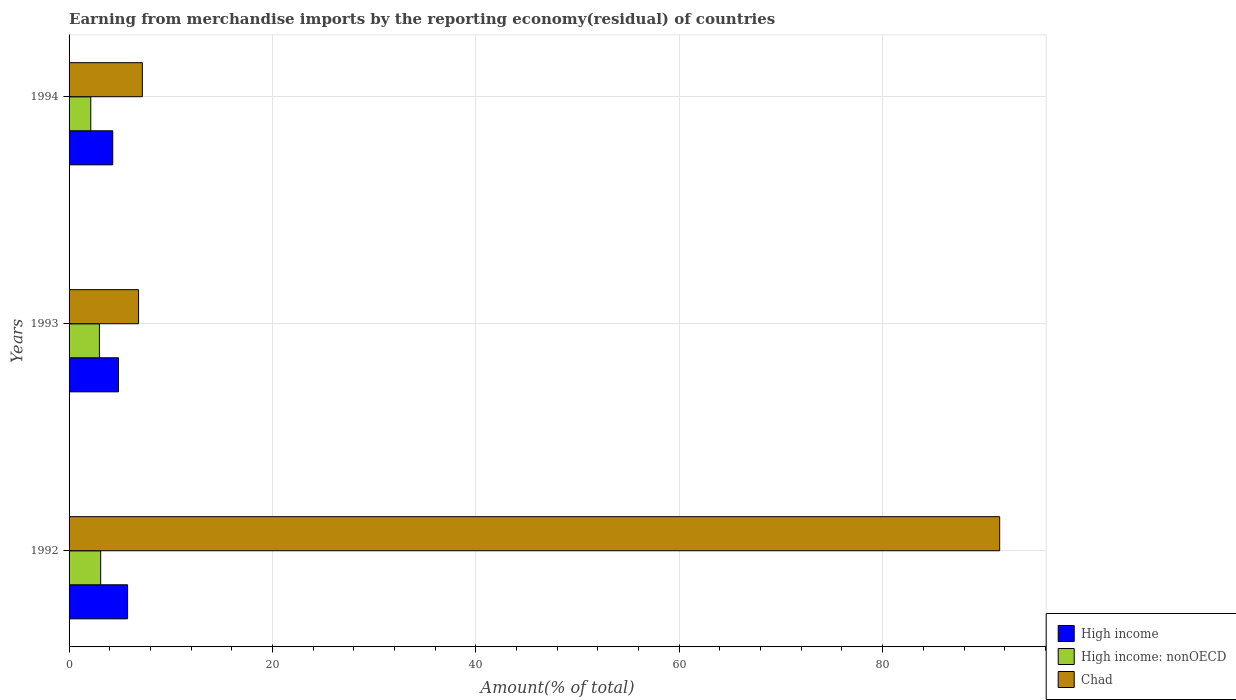How many different coloured bars are there?
Keep it short and to the point. 3. Are the number of bars per tick equal to the number of legend labels?
Make the answer very short. Yes. How many bars are there on the 3rd tick from the top?
Your response must be concise. 3. What is the label of the 1st group of bars from the top?
Offer a very short reply. 1994. What is the percentage of amount earned from merchandise imports in High income: nonOECD in 1994?
Provide a succinct answer. 2.13. Across all years, what is the maximum percentage of amount earned from merchandise imports in High income?
Provide a succinct answer. 5.75. Across all years, what is the minimum percentage of amount earned from merchandise imports in Chad?
Your answer should be compact. 6.83. In which year was the percentage of amount earned from merchandise imports in Chad maximum?
Give a very brief answer. 1992. What is the total percentage of amount earned from merchandise imports in High income: nonOECD in the graph?
Give a very brief answer. 8.23. What is the difference between the percentage of amount earned from merchandise imports in High income in 1992 and that in 1993?
Offer a terse response. 0.89. What is the difference between the percentage of amount earned from merchandise imports in High income: nonOECD in 1992 and the percentage of amount earned from merchandise imports in High income in 1994?
Provide a succinct answer. -1.19. What is the average percentage of amount earned from merchandise imports in Chad per year?
Make the answer very short. 35.18. In the year 1993, what is the difference between the percentage of amount earned from merchandise imports in High income and percentage of amount earned from merchandise imports in Chad?
Ensure brevity in your answer.  -1.97. What is the ratio of the percentage of amount earned from merchandise imports in High income: nonOECD in 1992 to that in 1993?
Ensure brevity in your answer.  1.04. Is the percentage of amount earned from merchandise imports in High income: nonOECD in 1992 less than that in 1993?
Ensure brevity in your answer.  No. Is the difference between the percentage of amount earned from merchandise imports in High income in 1992 and 1993 greater than the difference between the percentage of amount earned from merchandise imports in Chad in 1992 and 1993?
Make the answer very short. No. What is the difference between the highest and the second highest percentage of amount earned from merchandise imports in Chad?
Keep it short and to the point. 84.3. What is the difference between the highest and the lowest percentage of amount earned from merchandise imports in High income: nonOECD?
Your response must be concise. 0.97. In how many years, is the percentage of amount earned from merchandise imports in High income greater than the average percentage of amount earned from merchandise imports in High income taken over all years?
Provide a short and direct response. 1. What does the 2nd bar from the top in 1992 represents?
Keep it short and to the point. High income: nonOECD. Are all the bars in the graph horizontal?
Ensure brevity in your answer.  Yes. How many years are there in the graph?
Provide a succinct answer. 3. Does the graph contain any zero values?
Provide a succinct answer. No. How are the legend labels stacked?
Keep it short and to the point. Vertical. What is the title of the graph?
Offer a terse response. Earning from merchandise imports by the reporting economy(residual) of countries. Does "Uganda" appear as one of the legend labels in the graph?
Offer a very short reply. No. What is the label or title of the X-axis?
Your response must be concise. Amount(% of total). What is the label or title of the Y-axis?
Keep it short and to the point. Years. What is the Amount(% of total) in High income in 1992?
Your answer should be very brief. 5.75. What is the Amount(% of total) of High income: nonOECD in 1992?
Your response must be concise. 3.11. What is the Amount(% of total) of Chad in 1992?
Provide a short and direct response. 91.5. What is the Amount(% of total) of High income in 1993?
Give a very brief answer. 4.86. What is the Amount(% of total) in High income: nonOECD in 1993?
Keep it short and to the point. 2.98. What is the Amount(% of total) in Chad in 1993?
Offer a very short reply. 6.83. What is the Amount(% of total) of High income in 1994?
Your response must be concise. 4.3. What is the Amount(% of total) in High income: nonOECD in 1994?
Your answer should be very brief. 2.13. What is the Amount(% of total) in Chad in 1994?
Make the answer very short. 7.21. Across all years, what is the maximum Amount(% of total) of High income?
Provide a short and direct response. 5.75. Across all years, what is the maximum Amount(% of total) in High income: nonOECD?
Ensure brevity in your answer.  3.11. Across all years, what is the maximum Amount(% of total) of Chad?
Ensure brevity in your answer.  91.5. Across all years, what is the minimum Amount(% of total) of High income?
Your response must be concise. 4.3. Across all years, what is the minimum Amount(% of total) of High income: nonOECD?
Provide a short and direct response. 2.13. Across all years, what is the minimum Amount(% of total) in Chad?
Your answer should be very brief. 6.83. What is the total Amount(% of total) of High income in the graph?
Give a very brief answer. 14.91. What is the total Amount(% of total) of High income: nonOECD in the graph?
Ensure brevity in your answer.  8.23. What is the total Amount(% of total) in Chad in the graph?
Give a very brief answer. 105.54. What is the difference between the Amount(% of total) of High income in 1992 and that in 1993?
Your response must be concise. 0.89. What is the difference between the Amount(% of total) in High income: nonOECD in 1992 and that in 1993?
Offer a very short reply. 0.13. What is the difference between the Amount(% of total) in Chad in 1992 and that in 1993?
Your answer should be very brief. 84.67. What is the difference between the Amount(% of total) in High income in 1992 and that in 1994?
Offer a very short reply. 1.46. What is the difference between the Amount(% of total) in High income: nonOECD in 1992 and that in 1994?
Give a very brief answer. 0.97. What is the difference between the Amount(% of total) of Chad in 1992 and that in 1994?
Make the answer very short. 84.3. What is the difference between the Amount(% of total) of High income in 1993 and that in 1994?
Your answer should be compact. 0.56. What is the difference between the Amount(% of total) in High income: nonOECD in 1993 and that in 1994?
Your answer should be compact. 0.85. What is the difference between the Amount(% of total) of Chad in 1993 and that in 1994?
Your answer should be compact. -0.37. What is the difference between the Amount(% of total) of High income in 1992 and the Amount(% of total) of High income: nonOECD in 1993?
Your answer should be compact. 2.77. What is the difference between the Amount(% of total) in High income in 1992 and the Amount(% of total) in Chad in 1993?
Make the answer very short. -1.08. What is the difference between the Amount(% of total) of High income: nonOECD in 1992 and the Amount(% of total) of Chad in 1993?
Provide a short and direct response. -3.72. What is the difference between the Amount(% of total) in High income in 1992 and the Amount(% of total) in High income: nonOECD in 1994?
Make the answer very short. 3.62. What is the difference between the Amount(% of total) of High income in 1992 and the Amount(% of total) of Chad in 1994?
Provide a succinct answer. -1.45. What is the difference between the Amount(% of total) in High income: nonOECD in 1992 and the Amount(% of total) in Chad in 1994?
Keep it short and to the point. -4.1. What is the difference between the Amount(% of total) in High income in 1993 and the Amount(% of total) in High income: nonOECD in 1994?
Your response must be concise. 2.72. What is the difference between the Amount(% of total) in High income in 1993 and the Amount(% of total) in Chad in 1994?
Offer a terse response. -2.35. What is the difference between the Amount(% of total) of High income: nonOECD in 1993 and the Amount(% of total) of Chad in 1994?
Provide a succinct answer. -4.22. What is the average Amount(% of total) in High income per year?
Your answer should be compact. 4.97. What is the average Amount(% of total) in High income: nonOECD per year?
Offer a terse response. 2.74. What is the average Amount(% of total) of Chad per year?
Provide a short and direct response. 35.18. In the year 1992, what is the difference between the Amount(% of total) of High income and Amount(% of total) of High income: nonOECD?
Provide a short and direct response. 2.64. In the year 1992, what is the difference between the Amount(% of total) of High income and Amount(% of total) of Chad?
Provide a succinct answer. -85.75. In the year 1992, what is the difference between the Amount(% of total) in High income: nonOECD and Amount(% of total) in Chad?
Ensure brevity in your answer.  -88.39. In the year 1993, what is the difference between the Amount(% of total) in High income and Amount(% of total) in High income: nonOECD?
Offer a terse response. 1.88. In the year 1993, what is the difference between the Amount(% of total) of High income and Amount(% of total) of Chad?
Offer a very short reply. -1.97. In the year 1993, what is the difference between the Amount(% of total) in High income: nonOECD and Amount(% of total) in Chad?
Your response must be concise. -3.85. In the year 1994, what is the difference between the Amount(% of total) in High income and Amount(% of total) in High income: nonOECD?
Offer a terse response. 2.16. In the year 1994, what is the difference between the Amount(% of total) of High income and Amount(% of total) of Chad?
Offer a terse response. -2.91. In the year 1994, what is the difference between the Amount(% of total) of High income: nonOECD and Amount(% of total) of Chad?
Keep it short and to the point. -5.07. What is the ratio of the Amount(% of total) of High income in 1992 to that in 1993?
Offer a terse response. 1.18. What is the ratio of the Amount(% of total) of High income: nonOECD in 1992 to that in 1993?
Provide a short and direct response. 1.04. What is the ratio of the Amount(% of total) in Chad in 1992 to that in 1993?
Your answer should be compact. 13.39. What is the ratio of the Amount(% of total) of High income in 1992 to that in 1994?
Make the answer very short. 1.34. What is the ratio of the Amount(% of total) of High income: nonOECD in 1992 to that in 1994?
Keep it short and to the point. 1.46. What is the ratio of the Amount(% of total) of Chad in 1992 to that in 1994?
Give a very brief answer. 12.7. What is the ratio of the Amount(% of total) of High income in 1993 to that in 1994?
Provide a short and direct response. 1.13. What is the ratio of the Amount(% of total) of High income: nonOECD in 1993 to that in 1994?
Your response must be concise. 1.4. What is the ratio of the Amount(% of total) in Chad in 1993 to that in 1994?
Make the answer very short. 0.95. What is the difference between the highest and the second highest Amount(% of total) in High income?
Give a very brief answer. 0.89. What is the difference between the highest and the second highest Amount(% of total) of High income: nonOECD?
Keep it short and to the point. 0.13. What is the difference between the highest and the second highest Amount(% of total) of Chad?
Your answer should be compact. 84.3. What is the difference between the highest and the lowest Amount(% of total) in High income?
Your response must be concise. 1.46. What is the difference between the highest and the lowest Amount(% of total) of High income: nonOECD?
Make the answer very short. 0.97. What is the difference between the highest and the lowest Amount(% of total) in Chad?
Give a very brief answer. 84.67. 